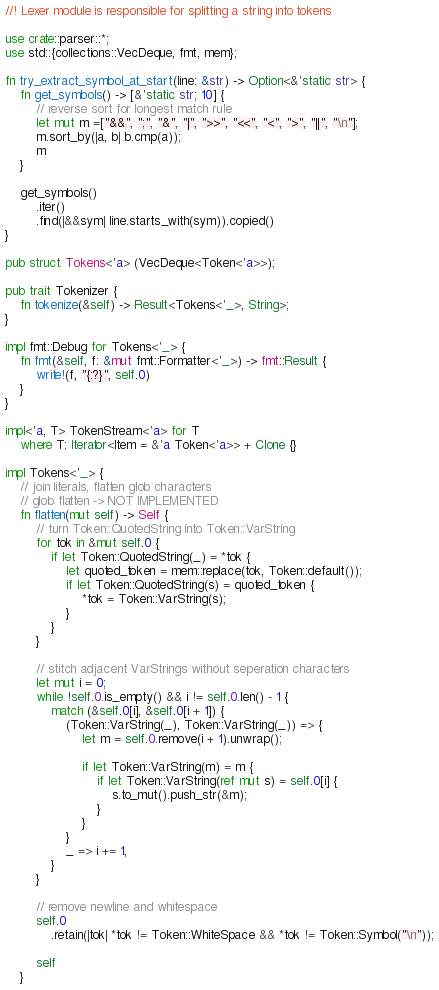Convert code to text. <code><loc_0><loc_0><loc_500><loc_500><_Rust_>//! Lexer module is responsible for splitting a string into tokens

use crate::parser::*;
use std::{collections::VecDeque, fmt, mem};

fn try_extract_symbol_at_start(line: &str) -> Option<&'static str> {
    fn get_symbols() -> [&'static str; 10] {
        // reverse sort for longest match rule
        let mut m =["&&", ";", "&", "|", ">>", "<<", "<", ">", "||", "\n"];
        m.sort_by(|a, b| b.cmp(a));
        m
    }

    get_symbols()
        .iter()
        .find(|&&sym| line.starts_with(sym)).copied()
}

pub struct Tokens<'a> (VecDeque<Token<'a>>);

pub trait Tokenizer {
    fn tokenize(&self) -> Result<Tokens<'_>, String>;
}

impl fmt::Debug for Tokens<'_> {
    fn fmt(&self, f: &mut fmt::Formatter<'_>) -> fmt::Result {
        write!(f, "{:?}", self.0)
    }
}

impl<'a, T> TokenStream<'a> for T 
    where T: Iterator<Item = &'a Token<'a>> + Clone {}

impl Tokens<'_> {
    // join literals, flatten glob characters
    // glob flatten -> NOT IMPLEMENTED
    fn flatten(mut self) -> Self {
        // turn Token::QuotedString into Token::VarString
        for tok in &mut self.0 {
            if let Token::QuotedString(_) = *tok {
                let quoted_token = mem::replace(tok, Token::default());
                if let Token::QuotedString(s) = quoted_token {
                    *tok = Token::VarString(s);
                }
            }
        }

        // stitch adjacent VarStrings without seperation characters
        let mut i = 0;
        while !self.0.is_empty() && i != self.0.len() - 1 {
            match (&self.0[i], &self.0[i + 1]) {
                (Token::VarString(_), Token::VarString(_)) => {
                    let m = self.0.remove(i + 1).unwrap();

                    if let Token::VarString(m) = m {
                        if let Token::VarString(ref mut s) = self.0[i] {
                            s.to_mut().push_str(&m);
                        }
                    }
                }
                _ => i += 1,
            }
        }

        // remove newline and whitespace
        self.0
            .retain(|tok| *tok != Token::WhiteSpace && *tok != Token::Symbol("\n"));

        self
    }
</code> 